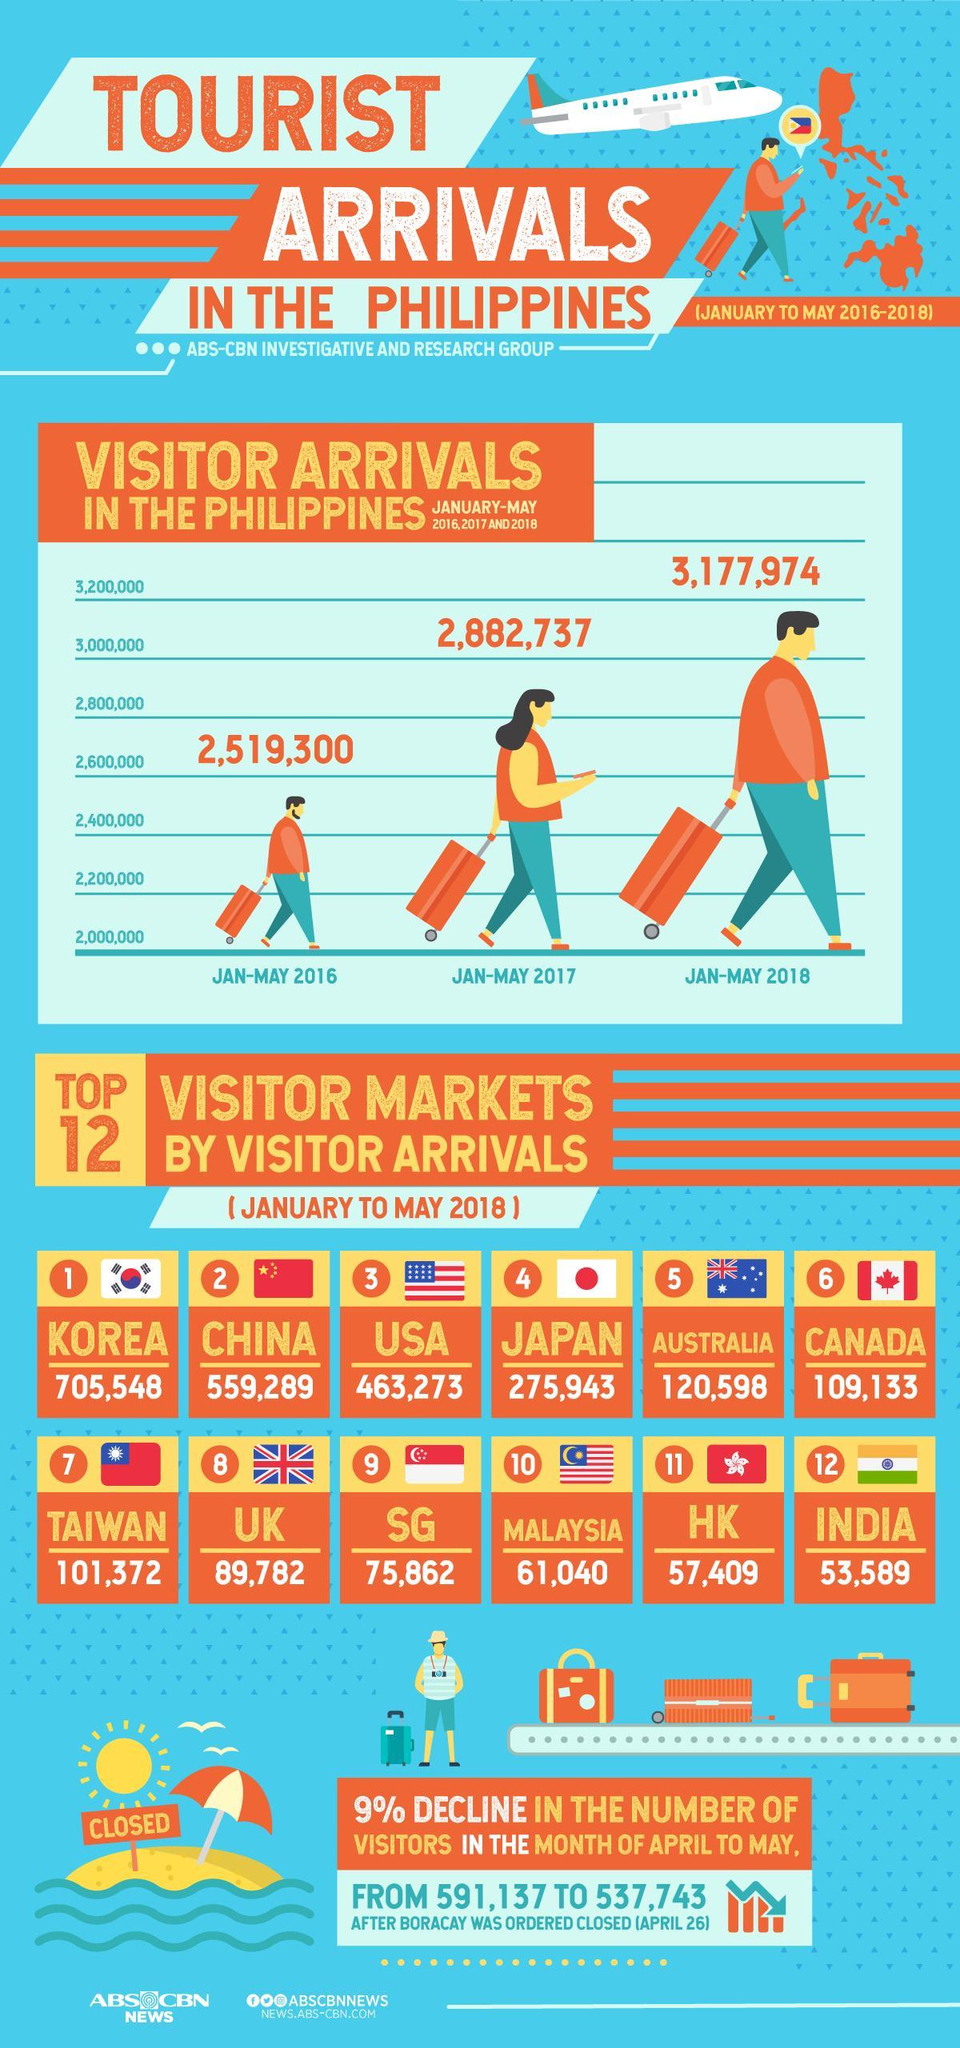What is the difference between the visitor's arrival in Jan-May 2018 and 2017, taken together?
Answer the question with a short phrase. 295237 What is the difference between the visitor's arrival in Jan-May 2017 and 2016, taken together? 363437 What is the number of visitor arrivals in Canada and HK, taken together? 166542 What is the number of visitor arrivals in Korea and India, taken together? 759137 What is the number of visitor arrivals in Japan and SG, taken together? 351805 